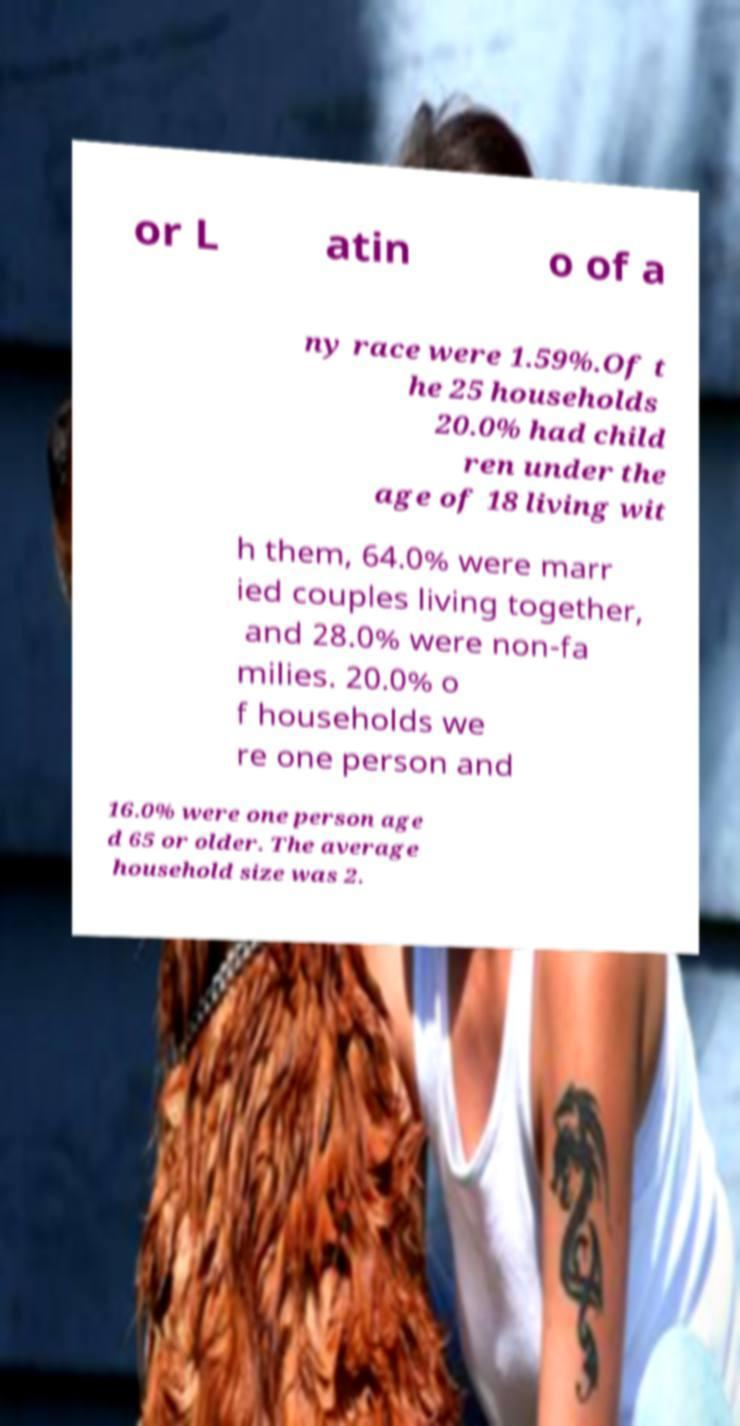Please read and relay the text visible in this image. What does it say? or L atin o of a ny race were 1.59%.Of t he 25 households 20.0% had child ren under the age of 18 living wit h them, 64.0% were marr ied couples living together, and 28.0% were non-fa milies. 20.0% o f households we re one person and 16.0% were one person age d 65 or older. The average household size was 2. 